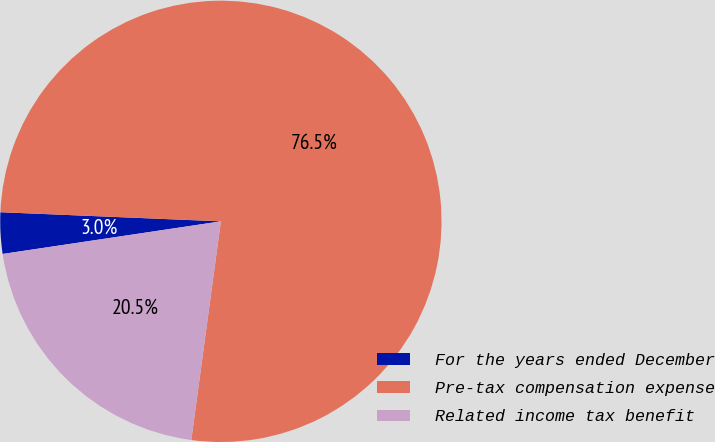<chart> <loc_0><loc_0><loc_500><loc_500><pie_chart><fcel>For the years ended December<fcel>Pre-tax compensation expense<fcel>Related income tax benefit<nl><fcel>3.02%<fcel>76.48%<fcel>20.5%<nl></chart> 